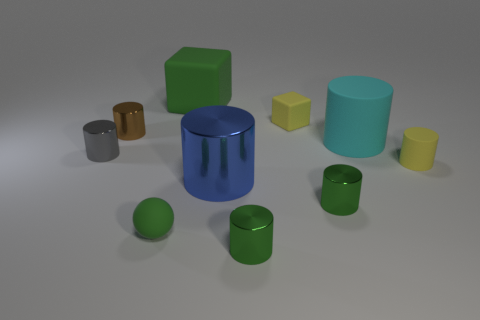How many cylinders have the same size as the green ball?
Ensure brevity in your answer.  5. What shape is the rubber thing that is the same color as the big rubber cube?
Give a very brief answer. Sphere. Are there any tiny blue shiny spheres?
Give a very brief answer. No. There is a yellow thing behind the yellow matte cylinder; is it the same shape as the green thing that is behind the yellow rubber cylinder?
Offer a terse response. Yes. What number of tiny objects are either rubber objects or green cubes?
Your response must be concise. 3. There is a gray thing that is made of the same material as the blue cylinder; what is its shape?
Provide a succinct answer. Cylinder. Is the tiny brown object the same shape as the big green rubber thing?
Offer a very short reply. No. The small block has what color?
Your answer should be very brief. Yellow. What number of objects are either tiny yellow rubber things or tiny cyan cubes?
Provide a short and direct response. 2. Are there fewer gray cylinders right of the small yellow cylinder than gray cylinders?
Provide a succinct answer. Yes. 